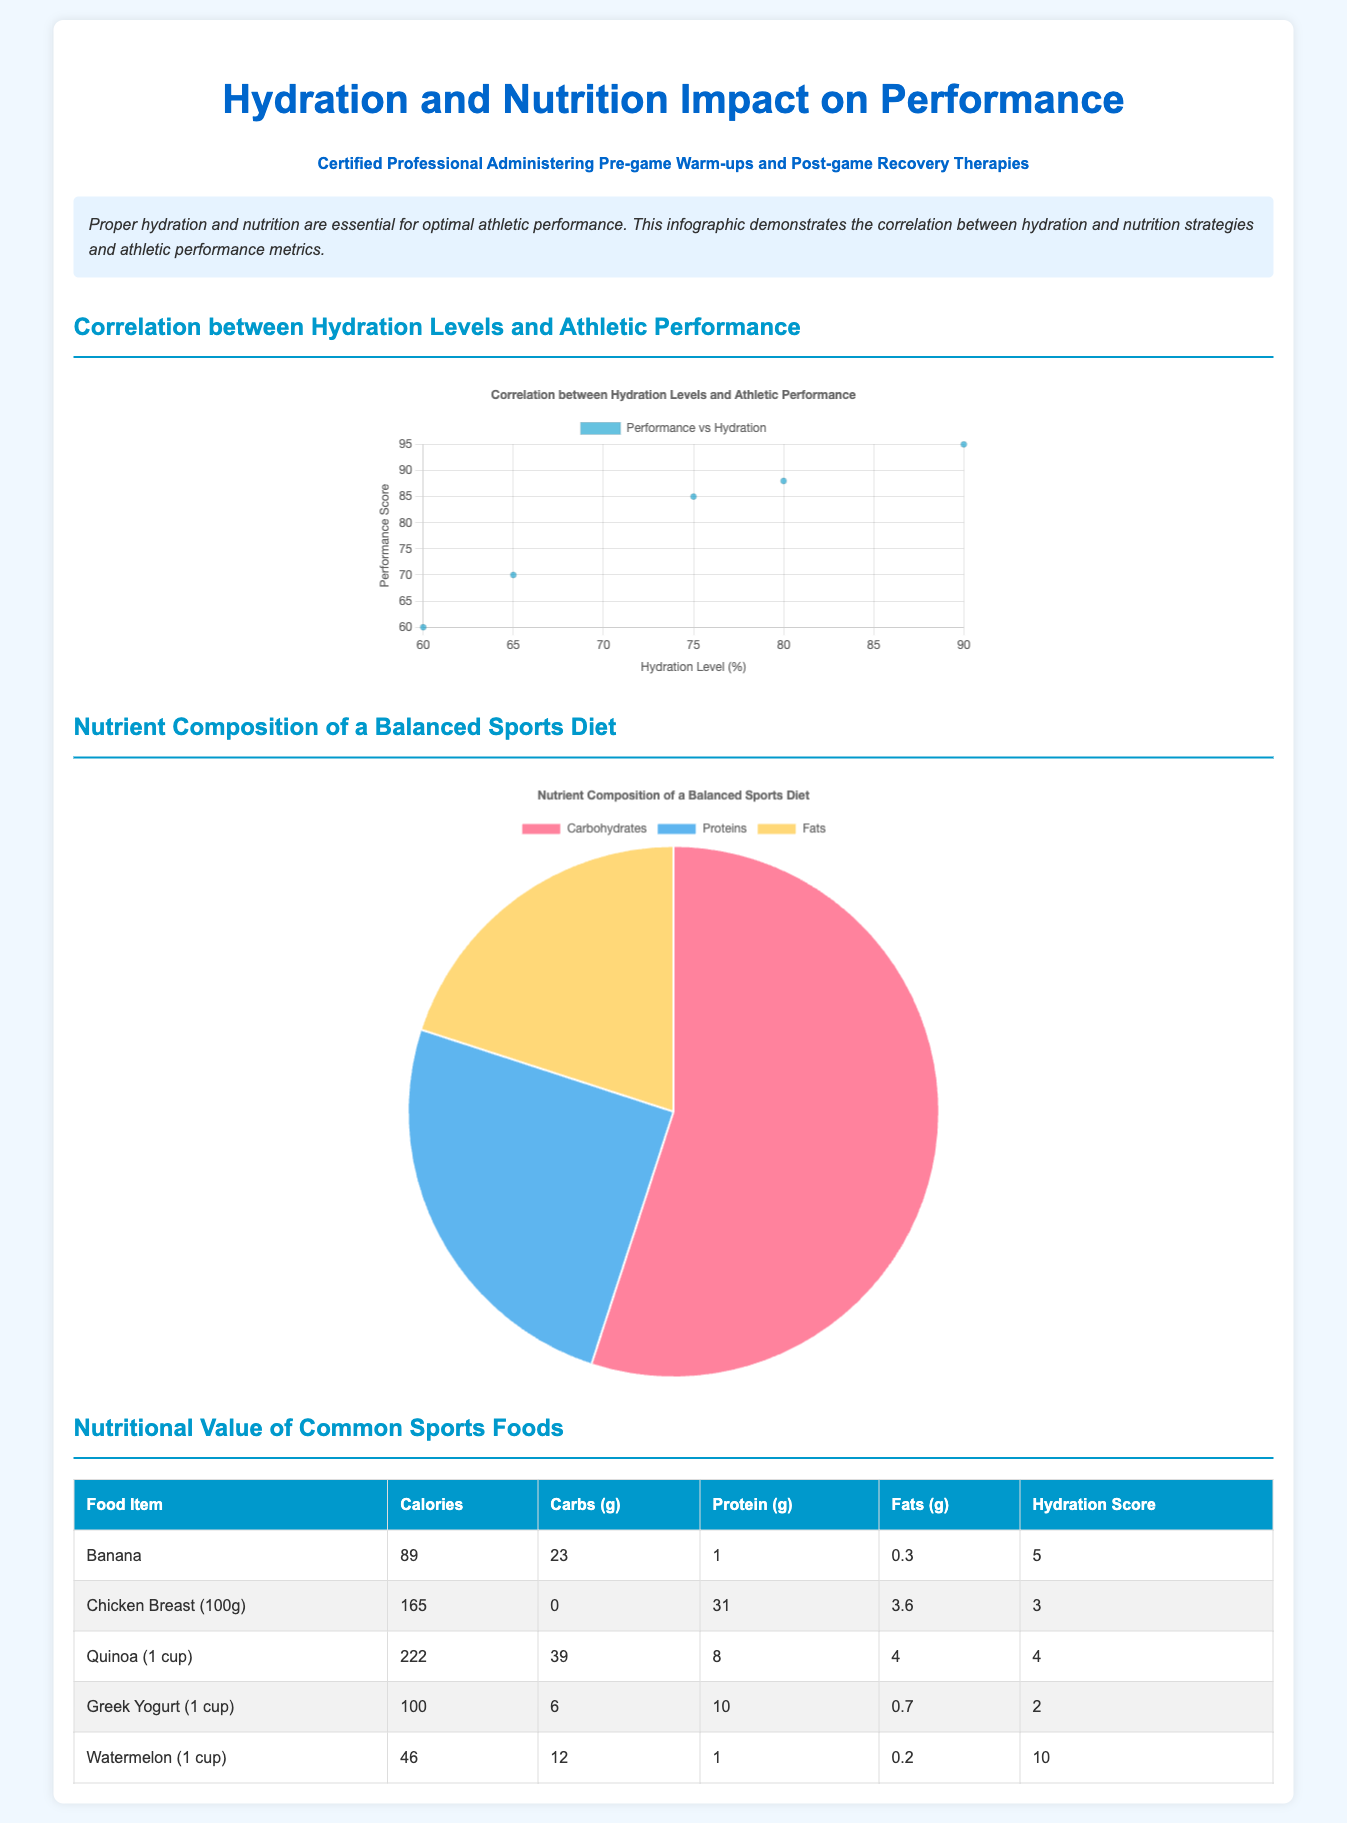What is the title of the infographic? The title is prominently displayed at the top of the document, indicating the main topic covered.
Answer: Hydration and Nutrition Impact on Performance What percentage of the balanced sports diet is allocated to carbohydrates? The pie chart highlights the divisions of nutrients in the diet, showing the allocation for carbohydrates.
Answer: 55 What is the hydration score of watermelon? The nutritional value table includes a hydration score for each food item, specifically showing watermelon’s score.
Answer: 10 What hydration level corresponds to a performance score of 95? The scatter plot relates hydration levels with performance scores, demonstrating the hydration level for a specific performance score.
Answer: 90 How many grams of protein are in chicken breast (100g)? The nutritional value table details the protein content of various food items, specifically for chicken breast.
Answer: 31 What is the color of the performance vs hydration scatter plot points? The scatter plot's dataset indicates the color used for the data points representing the relationship between hydration levels and performance.
Answer: rgba(0, 153, 204, 0.6) Which nutrient is represented by the smallest slice in the pie chart? The pie chart visually represents the nutrient composition, showing which has the least portion.
Answer: Fats What is the performance score for a hydration level of 60%? The scatter plot shows the corresponding performance score for that hydration level as indicated in the dataset.
Answer: 60 What food item has the highest calories in the table? The nutritional value table lists food items along with their caloric content, indicating which has the most.
Answer: Chicken Breast (100g) 